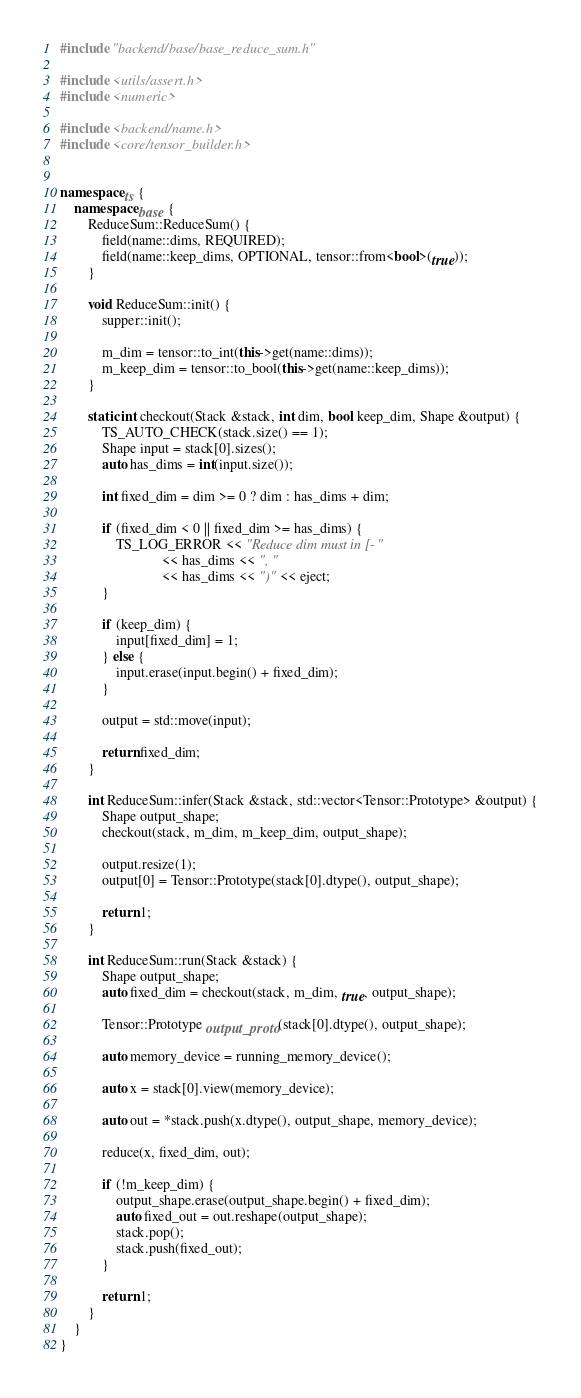Convert code to text. <code><loc_0><loc_0><loc_500><loc_500><_C++_>
#include "backend/base/base_reduce_sum.h"

#include <utils/assert.h>
#include <numeric>

#include <backend/name.h>
#include <core/tensor_builder.h>


namespace ts {
    namespace base {
        ReduceSum::ReduceSum() {
            field(name::dims, REQUIRED);
            field(name::keep_dims, OPTIONAL, tensor::from<bool>(true));
        }

        void ReduceSum::init() {
            supper::init();

            m_dim = tensor::to_int(this->get(name::dims));
            m_keep_dim = tensor::to_bool(this->get(name::keep_dims));
        }

        static int checkout(Stack &stack, int dim, bool keep_dim, Shape &output) {
            TS_AUTO_CHECK(stack.size() == 1);
            Shape input = stack[0].sizes();
            auto has_dims = int(input.size());

            int fixed_dim = dim >= 0 ? dim : has_dims + dim;

            if (fixed_dim < 0 || fixed_dim >= has_dims) {
                TS_LOG_ERROR << "Reduce dim must in [-"
                             << has_dims << ", "
                             << has_dims << ")" << eject;
            }

            if (keep_dim) {
                input[fixed_dim] = 1;
            } else {
                input.erase(input.begin() + fixed_dim);
            }

            output = std::move(input);

            return fixed_dim;
        }

        int ReduceSum::infer(Stack &stack, std::vector<Tensor::Prototype> &output) {
            Shape output_shape;
            checkout(stack, m_dim, m_keep_dim, output_shape);

            output.resize(1);
            output[0] = Tensor::Prototype(stack[0].dtype(), output_shape);

            return 1;
        }

        int ReduceSum::run(Stack &stack) {
            Shape output_shape;
            auto fixed_dim = checkout(stack, m_dim, true, output_shape);

            Tensor::Prototype output_proto(stack[0].dtype(), output_shape);

            auto memory_device = running_memory_device();

            auto x = stack[0].view(memory_device);

            auto out = *stack.push(x.dtype(), output_shape, memory_device);

            reduce(x, fixed_dim, out);

            if (!m_keep_dim) {
                output_shape.erase(output_shape.begin() + fixed_dim);
                auto fixed_out = out.reshape(output_shape);
                stack.pop();
                stack.push(fixed_out);
            }

            return 1;
        }
    }
}
</code> 